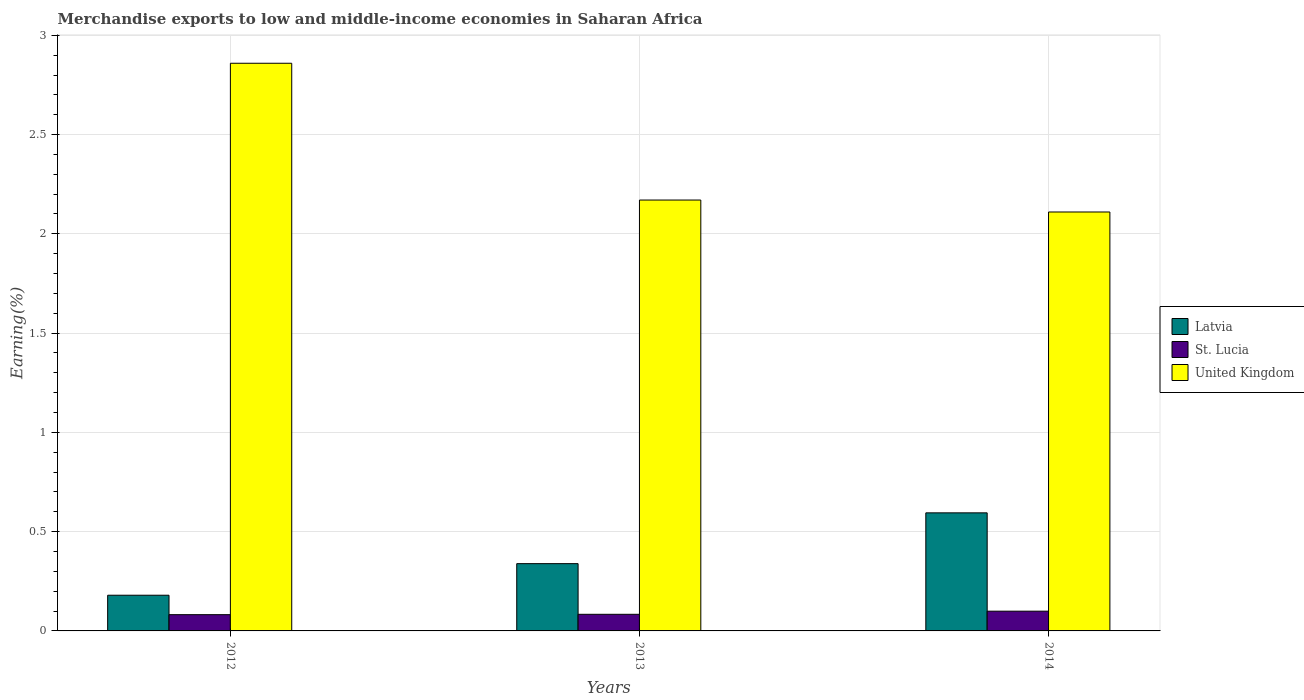Are the number of bars per tick equal to the number of legend labels?
Ensure brevity in your answer.  Yes. What is the label of the 2nd group of bars from the left?
Your answer should be compact. 2013. In how many cases, is the number of bars for a given year not equal to the number of legend labels?
Offer a terse response. 0. What is the percentage of amount earned from merchandise exports in St. Lucia in 2012?
Make the answer very short. 0.08. Across all years, what is the maximum percentage of amount earned from merchandise exports in St. Lucia?
Your answer should be very brief. 0.1. Across all years, what is the minimum percentage of amount earned from merchandise exports in United Kingdom?
Give a very brief answer. 2.11. What is the total percentage of amount earned from merchandise exports in St. Lucia in the graph?
Ensure brevity in your answer.  0.27. What is the difference between the percentage of amount earned from merchandise exports in United Kingdom in 2013 and that in 2014?
Your answer should be very brief. 0.06. What is the difference between the percentage of amount earned from merchandise exports in United Kingdom in 2014 and the percentage of amount earned from merchandise exports in St. Lucia in 2012?
Your response must be concise. 2.03. What is the average percentage of amount earned from merchandise exports in Latvia per year?
Provide a succinct answer. 0.37. In the year 2014, what is the difference between the percentage of amount earned from merchandise exports in Latvia and percentage of amount earned from merchandise exports in St. Lucia?
Make the answer very short. 0.5. In how many years, is the percentage of amount earned from merchandise exports in United Kingdom greater than 1.5 %?
Your answer should be very brief. 3. What is the ratio of the percentage of amount earned from merchandise exports in United Kingdom in 2012 to that in 2013?
Offer a terse response. 1.32. Is the percentage of amount earned from merchandise exports in Latvia in 2013 less than that in 2014?
Offer a very short reply. Yes. What is the difference between the highest and the second highest percentage of amount earned from merchandise exports in St. Lucia?
Your response must be concise. 0.02. What is the difference between the highest and the lowest percentage of amount earned from merchandise exports in United Kingdom?
Make the answer very short. 0.75. What does the 2nd bar from the left in 2014 represents?
Your answer should be compact. St. Lucia. What does the 3rd bar from the right in 2012 represents?
Your answer should be compact. Latvia. Is it the case that in every year, the sum of the percentage of amount earned from merchandise exports in United Kingdom and percentage of amount earned from merchandise exports in St. Lucia is greater than the percentage of amount earned from merchandise exports in Latvia?
Offer a terse response. Yes. How many bars are there?
Provide a short and direct response. 9. Are all the bars in the graph horizontal?
Make the answer very short. No. How many years are there in the graph?
Make the answer very short. 3. Are the values on the major ticks of Y-axis written in scientific E-notation?
Your response must be concise. No. Where does the legend appear in the graph?
Offer a terse response. Center right. What is the title of the graph?
Give a very brief answer. Merchandise exports to low and middle-income economies in Saharan Africa. What is the label or title of the Y-axis?
Give a very brief answer. Earning(%). What is the Earning(%) of Latvia in 2012?
Keep it short and to the point. 0.18. What is the Earning(%) of St. Lucia in 2012?
Your answer should be compact. 0.08. What is the Earning(%) of United Kingdom in 2012?
Your answer should be compact. 2.86. What is the Earning(%) of Latvia in 2013?
Provide a succinct answer. 0.34. What is the Earning(%) in St. Lucia in 2013?
Make the answer very short. 0.08. What is the Earning(%) in United Kingdom in 2013?
Provide a short and direct response. 2.17. What is the Earning(%) of Latvia in 2014?
Provide a succinct answer. 0.59. What is the Earning(%) in St. Lucia in 2014?
Your response must be concise. 0.1. What is the Earning(%) of United Kingdom in 2014?
Provide a short and direct response. 2.11. Across all years, what is the maximum Earning(%) of Latvia?
Provide a short and direct response. 0.59. Across all years, what is the maximum Earning(%) of St. Lucia?
Make the answer very short. 0.1. Across all years, what is the maximum Earning(%) of United Kingdom?
Your response must be concise. 2.86. Across all years, what is the minimum Earning(%) in Latvia?
Ensure brevity in your answer.  0.18. Across all years, what is the minimum Earning(%) in St. Lucia?
Keep it short and to the point. 0.08. Across all years, what is the minimum Earning(%) in United Kingdom?
Provide a succinct answer. 2.11. What is the total Earning(%) in Latvia in the graph?
Provide a short and direct response. 1.11. What is the total Earning(%) of St. Lucia in the graph?
Your answer should be very brief. 0.27. What is the total Earning(%) in United Kingdom in the graph?
Make the answer very short. 7.14. What is the difference between the Earning(%) in Latvia in 2012 and that in 2013?
Ensure brevity in your answer.  -0.16. What is the difference between the Earning(%) in St. Lucia in 2012 and that in 2013?
Your response must be concise. -0. What is the difference between the Earning(%) in United Kingdom in 2012 and that in 2013?
Provide a short and direct response. 0.69. What is the difference between the Earning(%) in Latvia in 2012 and that in 2014?
Provide a succinct answer. -0.41. What is the difference between the Earning(%) in St. Lucia in 2012 and that in 2014?
Your response must be concise. -0.02. What is the difference between the Earning(%) in United Kingdom in 2012 and that in 2014?
Ensure brevity in your answer.  0.75. What is the difference between the Earning(%) of Latvia in 2013 and that in 2014?
Your answer should be very brief. -0.26. What is the difference between the Earning(%) of St. Lucia in 2013 and that in 2014?
Make the answer very short. -0.02. What is the difference between the Earning(%) in United Kingdom in 2013 and that in 2014?
Your answer should be compact. 0.06. What is the difference between the Earning(%) in Latvia in 2012 and the Earning(%) in St. Lucia in 2013?
Offer a terse response. 0.1. What is the difference between the Earning(%) in Latvia in 2012 and the Earning(%) in United Kingdom in 2013?
Offer a terse response. -1.99. What is the difference between the Earning(%) of St. Lucia in 2012 and the Earning(%) of United Kingdom in 2013?
Offer a terse response. -2.09. What is the difference between the Earning(%) in Latvia in 2012 and the Earning(%) in St. Lucia in 2014?
Offer a terse response. 0.08. What is the difference between the Earning(%) of Latvia in 2012 and the Earning(%) of United Kingdom in 2014?
Provide a succinct answer. -1.93. What is the difference between the Earning(%) of St. Lucia in 2012 and the Earning(%) of United Kingdom in 2014?
Offer a very short reply. -2.03. What is the difference between the Earning(%) in Latvia in 2013 and the Earning(%) in St. Lucia in 2014?
Provide a succinct answer. 0.24. What is the difference between the Earning(%) in Latvia in 2013 and the Earning(%) in United Kingdom in 2014?
Provide a succinct answer. -1.77. What is the difference between the Earning(%) of St. Lucia in 2013 and the Earning(%) of United Kingdom in 2014?
Your response must be concise. -2.03. What is the average Earning(%) of Latvia per year?
Keep it short and to the point. 0.37. What is the average Earning(%) in St. Lucia per year?
Give a very brief answer. 0.09. What is the average Earning(%) of United Kingdom per year?
Your answer should be compact. 2.38. In the year 2012, what is the difference between the Earning(%) of Latvia and Earning(%) of St. Lucia?
Offer a very short reply. 0.1. In the year 2012, what is the difference between the Earning(%) in Latvia and Earning(%) in United Kingdom?
Provide a succinct answer. -2.68. In the year 2012, what is the difference between the Earning(%) of St. Lucia and Earning(%) of United Kingdom?
Keep it short and to the point. -2.78. In the year 2013, what is the difference between the Earning(%) of Latvia and Earning(%) of St. Lucia?
Offer a terse response. 0.26. In the year 2013, what is the difference between the Earning(%) of Latvia and Earning(%) of United Kingdom?
Make the answer very short. -1.83. In the year 2013, what is the difference between the Earning(%) of St. Lucia and Earning(%) of United Kingdom?
Provide a succinct answer. -2.09. In the year 2014, what is the difference between the Earning(%) in Latvia and Earning(%) in St. Lucia?
Give a very brief answer. 0.5. In the year 2014, what is the difference between the Earning(%) in Latvia and Earning(%) in United Kingdom?
Your response must be concise. -1.52. In the year 2014, what is the difference between the Earning(%) of St. Lucia and Earning(%) of United Kingdom?
Ensure brevity in your answer.  -2.01. What is the ratio of the Earning(%) in Latvia in 2012 to that in 2013?
Provide a short and direct response. 0.53. What is the ratio of the Earning(%) of St. Lucia in 2012 to that in 2013?
Your answer should be compact. 0.98. What is the ratio of the Earning(%) of United Kingdom in 2012 to that in 2013?
Keep it short and to the point. 1.32. What is the ratio of the Earning(%) in Latvia in 2012 to that in 2014?
Offer a terse response. 0.3. What is the ratio of the Earning(%) in St. Lucia in 2012 to that in 2014?
Your answer should be compact. 0.82. What is the ratio of the Earning(%) in United Kingdom in 2012 to that in 2014?
Make the answer very short. 1.35. What is the ratio of the Earning(%) of Latvia in 2013 to that in 2014?
Offer a very short reply. 0.57. What is the ratio of the Earning(%) of St. Lucia in 2013 to that in 2014?
Offer a very short reply. 0.84. What is the ratio of the Earning(%) in United Kingdom in 2013 to that in 2014?
Your response must be concise. 1.03. What is the difference between the highest and the second highest Earning(%) of Latvia?
Ensure brevity in your answer.  0.26. What is the difference between the highest and the second highest Earning(%) of St. Lucia?
Make the answer very short. 0.02. What is the difference between the highest and the second highest Earning(%) in United Kingdom?
Make the answer very short. 0.69. What is the difference between the highest and the lowest Earning(%) in Latvia?
Provide a short and direct response. 0.41. What is the difference between the highest and the lowest Earning(%) in St. Lucia?
Your answer should be very brief. 0.02. What is the difference between the highest and the lowest Earning(%) in United Kingdom?
Your response must be concise. 0.75. 